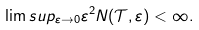<formula> <loc_0><loc_0><loc_500><loc_500>\lim s u p _ { \varepsilon \rightarrow 0 } \varepsilon ^ { 2 } N ( \mathcal { T } , \varepsilon ) < \infty .</formula> 